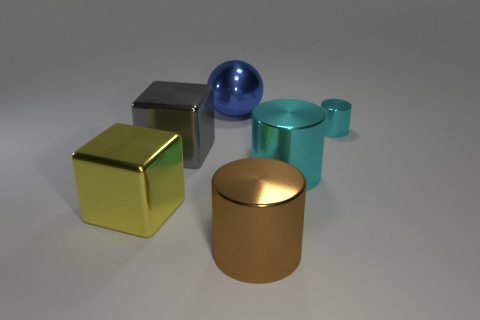Add 2 large cyan shiny objects. How many objects exist? 8 Subtract all balls. How many objects are left? 5 Subtract all big purple shiny cylinders. Subtract all yellow metallic blocks. How many objects are left? 5 Add 2 metal things. How many metal things are left? 8 Add 3 cyan metal cylinders. How many cyan metal cylinders exist? 5 Subtract 1 blue balls. How many objects are left? 5 